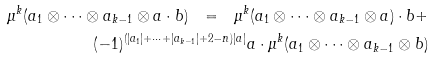<formula> <loc_0><loc_0><loc_500><loc_500>\mu ^ { k } ( a _ { 1 } \otimes \cdots \otimes a _ { k - 1 } \otimes a \cdot b ) \ = \ \mu ^ { k } ( a _ { 1 } \otimes \cdots \otimes a _ { k - 1 } \otimes a ) \cdot b + & & \\ ( - 1 ) ^ { ( | a _ { 1 } | + \cdots + | a _ { k - 1 } | + 2 - n ) | a | } a \cdot \mu ^ { k } ( a _ { 1 } \otimes \cdots \otimes a _ { k - 1 } \otimes b ) & &</formula> 